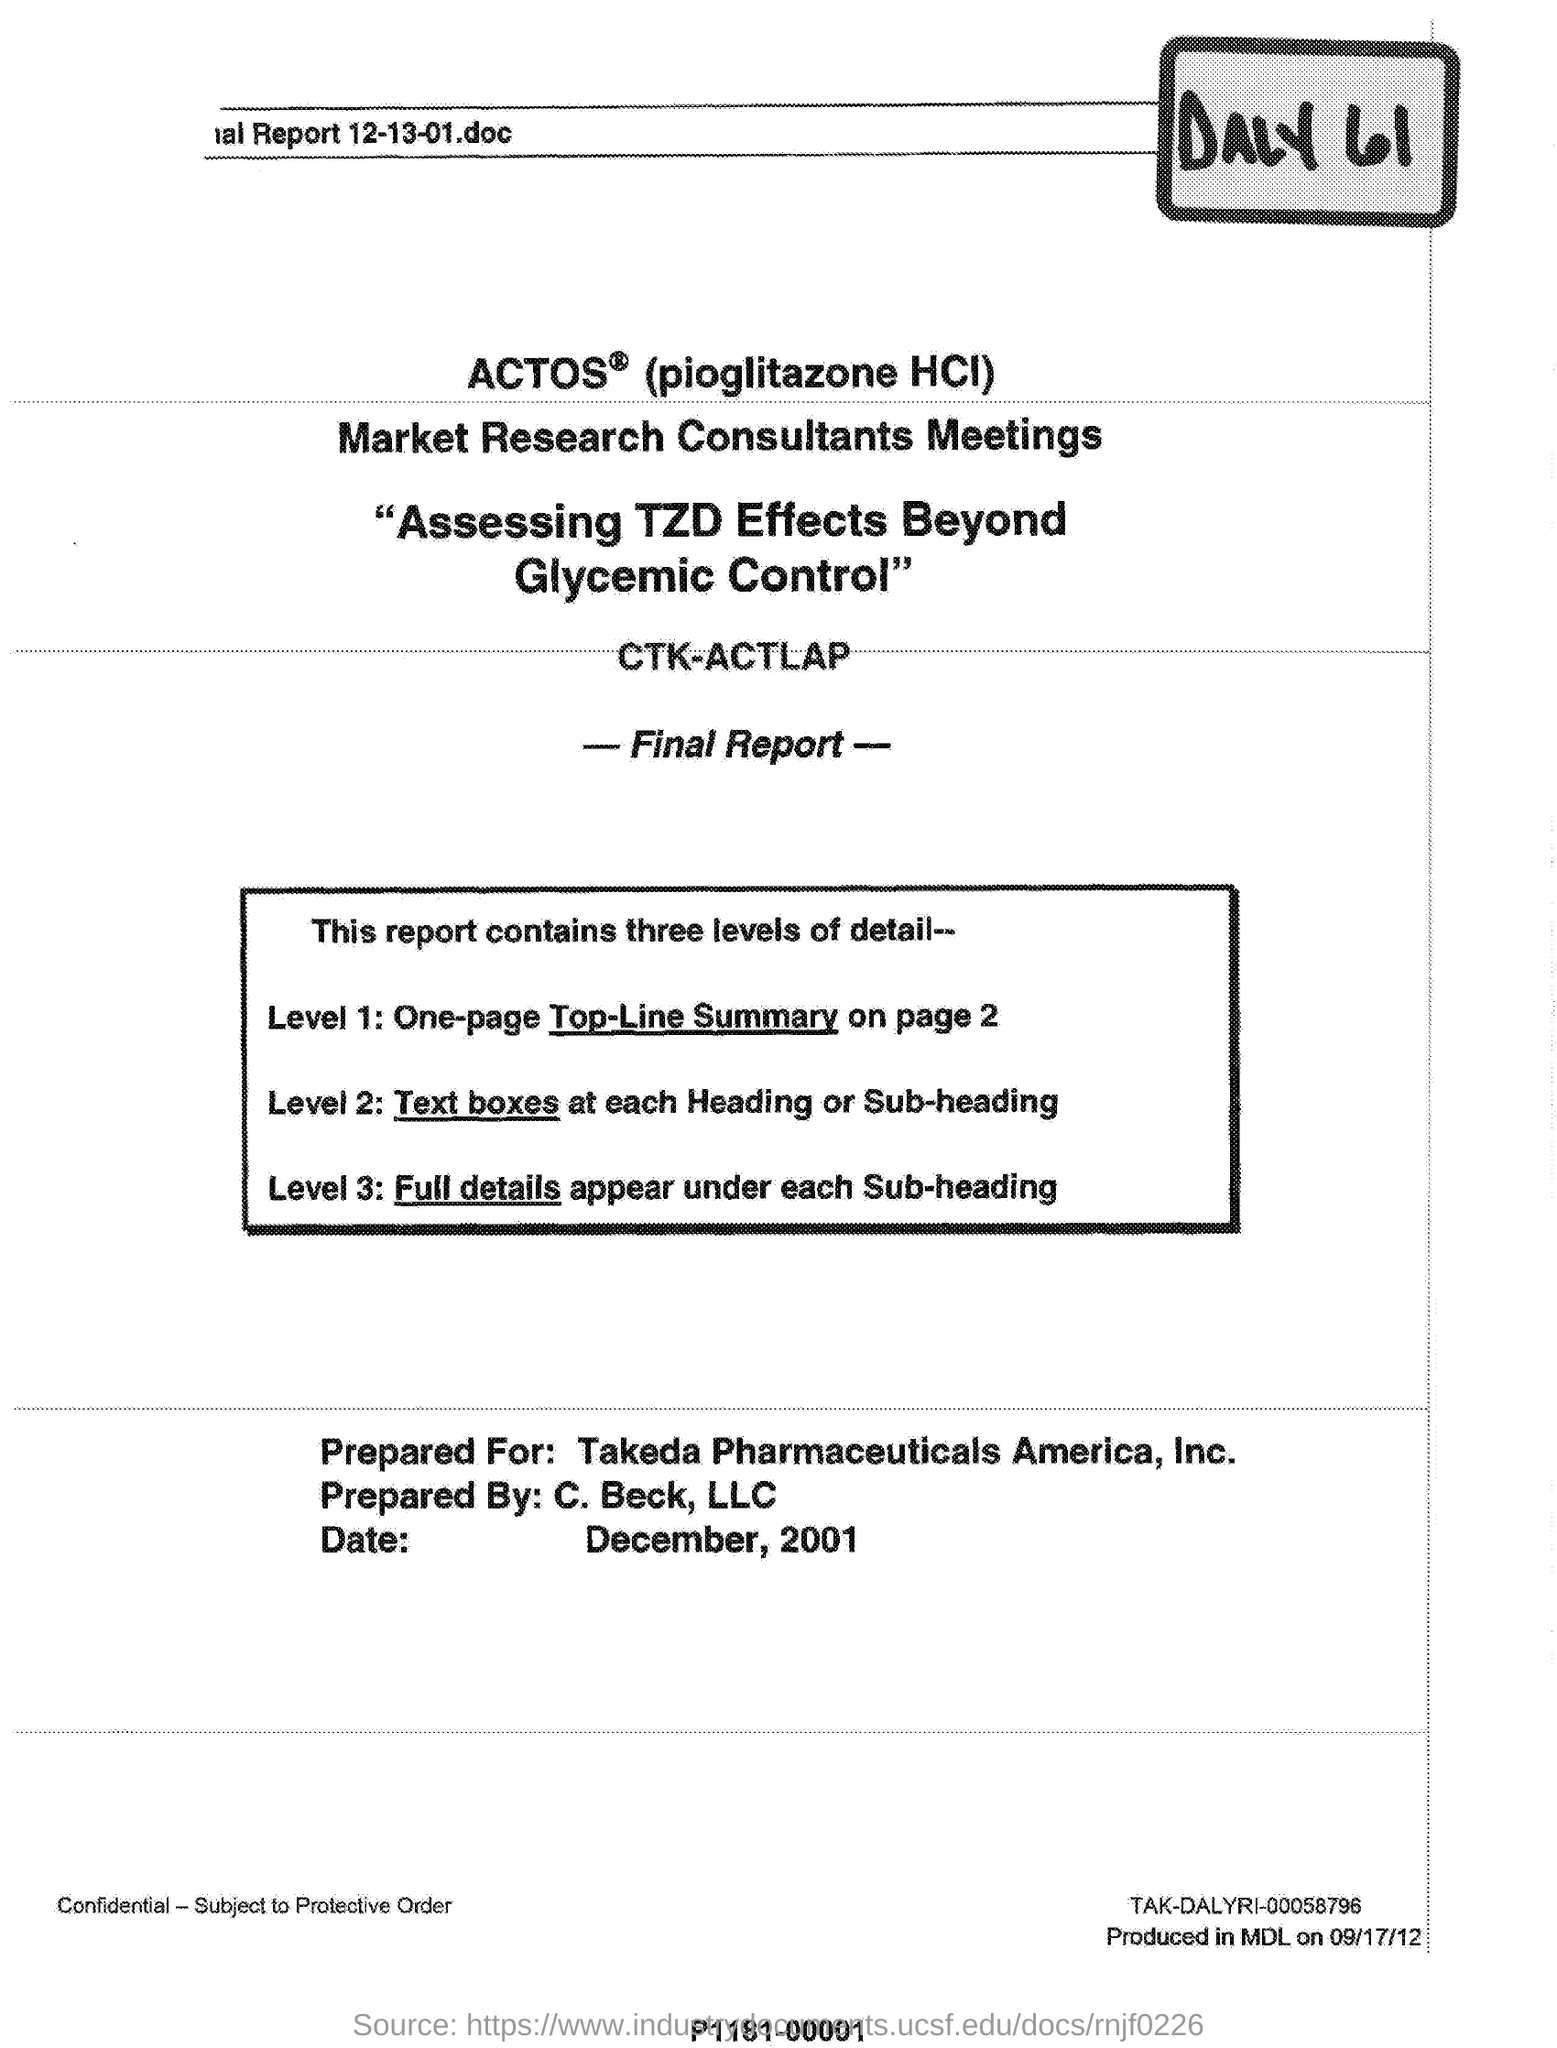What is the date mentioned?
Offer a terse response. December, 2001. By whom was this document prepared?
Provide a short and direct response. C. Beck. 